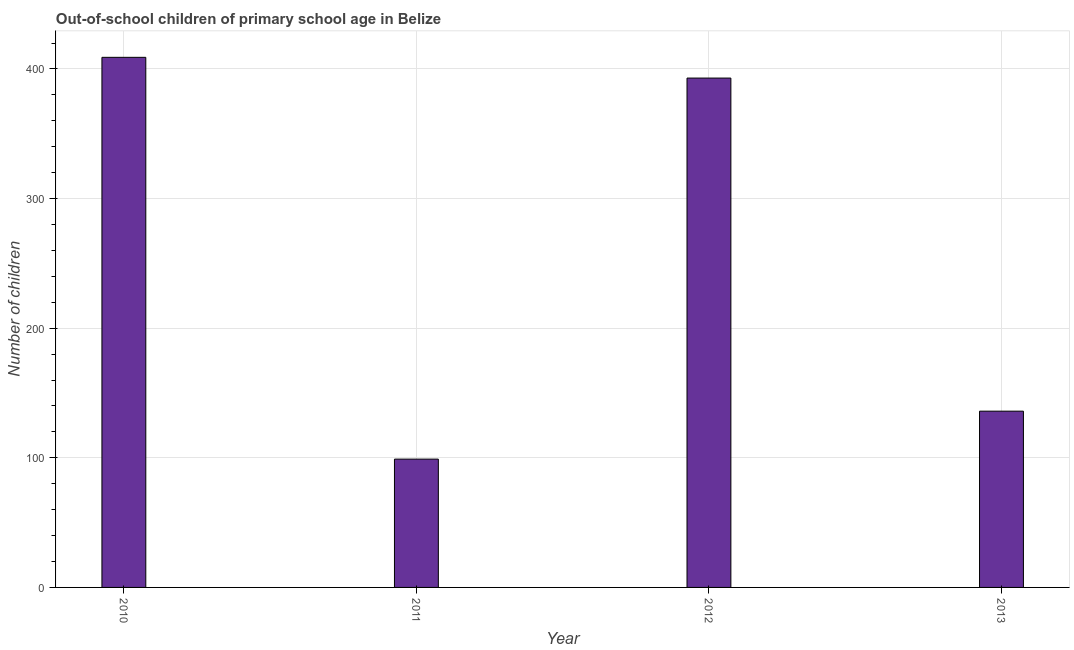Does the graph contain any zero values?
Provide a succinct answer. No. Does the graph contain grids?
Ensure brevity in your answer.  Yes. What is the title of the graph?
Provide a short and direct response. Out-of-school children of primary school age in Belize. What is the label or title of the Y-axis?
Keep it short and to the point. Number of children. What is the number of out-of-school children in 2013?
Provide a short and direct response. 136. Across all years, what is the maximum number of out-of-school children?
Provide a succinct answer. 409. In which year was the number of out-of-school children maximum?
Offer a very short reply. 2010. What is the sum of the number of out-of-school children?
Your answer should be compact. 1037. What is the difference between the number of out-of-school children in 2011 and 2013?
Keep it short and to the point. -37. What is the average number of out-of-school children per year?
Your answer should be compact. 259. What is the median number of out-of-school children?
Make the answer very short. 264.5. In how many years, is the number of out-of-school children greater than 380 ?
Offer a terse response. 2. What is the ratio of the number of out-of-school children in 2010 to that in 2012?
Offer a terse response. 1.04. Is the number of out-of-school children in 2012 less than that in 2013?
Provide a succinct answer. No. What is the difference between the highest and the lowest number of out-of-school children?
Ensure brevity in your answer.  310. In how many years, is the number of out-of-school children greater than the average number of out-of-school children taken over all years?
Provide a succinct answer. 2. How many years are there in the graph?
Offer a very short reply. 4. Are the values on the major ticks of Y-axis written in scientific E-notation?
Make the answer very short. No. What is the Number of children in 2010?
Your answer should be very brief. 409. What is the Number of children of 2012?
Keep it short and to the point. 393. What is the Number of children in 2013?
Offer a very short reply. 136. What is the difference between the Number of children in 2010 and 2011?
Your response must be concise. 310. What is the difference between the Number of children in 2010 and 2013?
Your answer should be very brief. 273. What is the difference between the Number of children in 2011 and 2012?
Your response must be concise. -294. What is the difference between the Number of children in 2011 and 2013?
Offer a very short reply. -37. What is the difference between the Number of children in 2012 and 2013?
Make the answer very short. 257. What is the ratio of the Number of children in 2010 to that in 2011?
Offer a terse response. 4.13. What is the ratio of the Number of children in 2010 to that in 2012?
Ensure brevity in your answer.  1.04. What is the ratio of the Number of children in 2010 to that in 2013?
Provide a succinct answer. 3.01. What is the ratio of the Number of children in 2011 to that in 2012?
Provide a succinct answer. 0.25. What is the ratio of the Number of children in 2011 to that in 2013?
Offer a terse response. 0.73. What is the ratio of the Number of children in 2012 to that in 2013?
Make the answer very short. 2.89. 